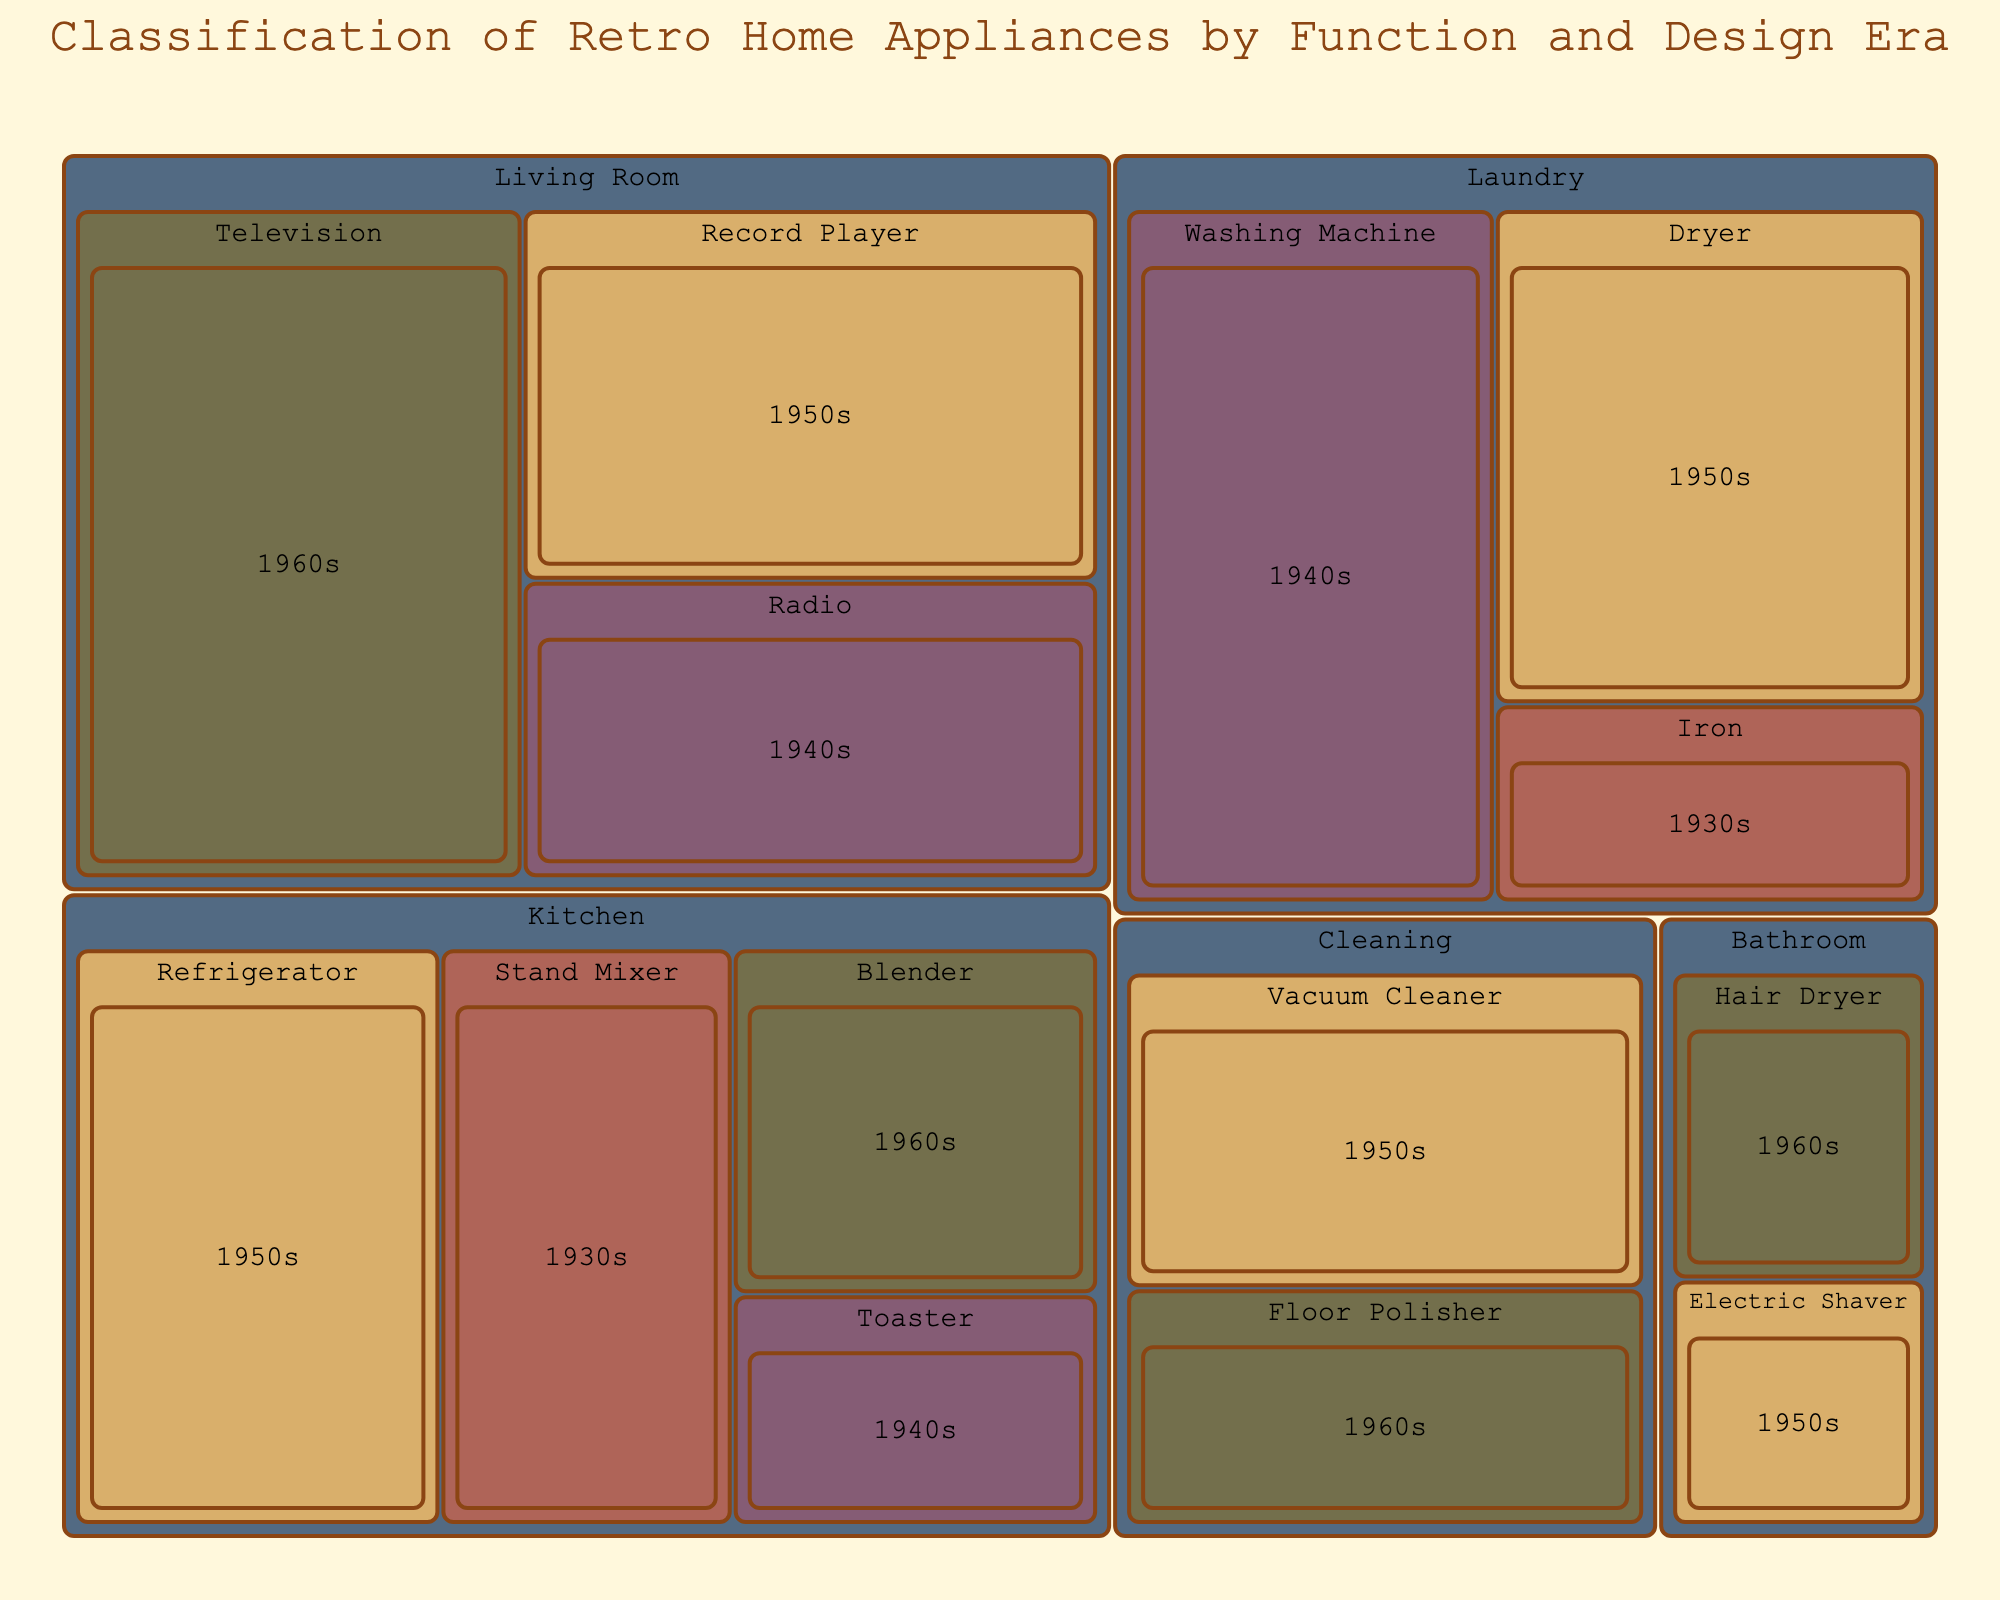What's the total value of Kitchen appliances? Locate all the Kitchen subcategories (Refrigerator, Blender, Toaster, Stand Mixer) and sum their values (25 + 15 + 10 + 20 = 70).
Answer: 70 Which subcategory in the Living Room has the highest value? Identify all Living Room subcategories (Television, Radio, Record Player) and compare their values (35, 20, 25). Television has the highest value of 35.
Answer: Television In which era do the most categories of appliances fall? Count the number of unique categories for each era: 1950s (Refrigerator, Dryer, Record Player, Vacuum Cleaner, Electric Shaver), 1960s (Blender, Television, Floor Polisher, Hair Dryer), 1940s (Toaster, Washing Machine, Radio), 1930s (Stand Mixer, Iron). The 1950s has the most categories with 5.
Answer: 1950s What is the sum of values for the 1930s era? Sum the values of all subcategories in the 1930s (Stand Mixer, Iron). The sum is (20 + 10 = 30).
Answer: 30 Which category has the greatest total value? Sum the values of each category and compare: Kitchen (70), Laundry (65), Living Room (80), Cleaning (35), Bathroom (18). The Living Room has the greatest total value of 80.
Answer: Living Room Which subcategory has the smallest value? Identify all subcategories and compare their values. The smallest value is Electric Shaver with 8.
Answer: Electric Shaver How many subcategories are there in the Cleaning category? Count the number of subcategories within Cleaning (Vacuum Cleaner, Floor Polisher). There are 2 subcategories.
Answer: 2 What is the average value of Bathroom appliances? Locate Bathroom subcategories (Hair Dryer, Electric Shaver) and calculate the average: (10 + 8)/2 = 9.
Answer: 9 What is the combined value of 1960s Living Room and Bathroom appliances? Sum the values of the 1960s Living Room (Television) and Bathroom (Hair Dryer) subcategories (35 + 10 = 45).
Answer: 45 Which category has appliances spanning the most different eras? Count the distinct eras within each category: Kitchen (1930s, 1940s, 1950s, 1960s), Laundry (1930s, 1940s, 1950s), Living Room (1940s, 1950s, 1960s), Cleaning (1950s, 1960s), Bathroom (1950s, 1960s). The category Kitchen spans the most eras with 4.
Answer: Kitchen 